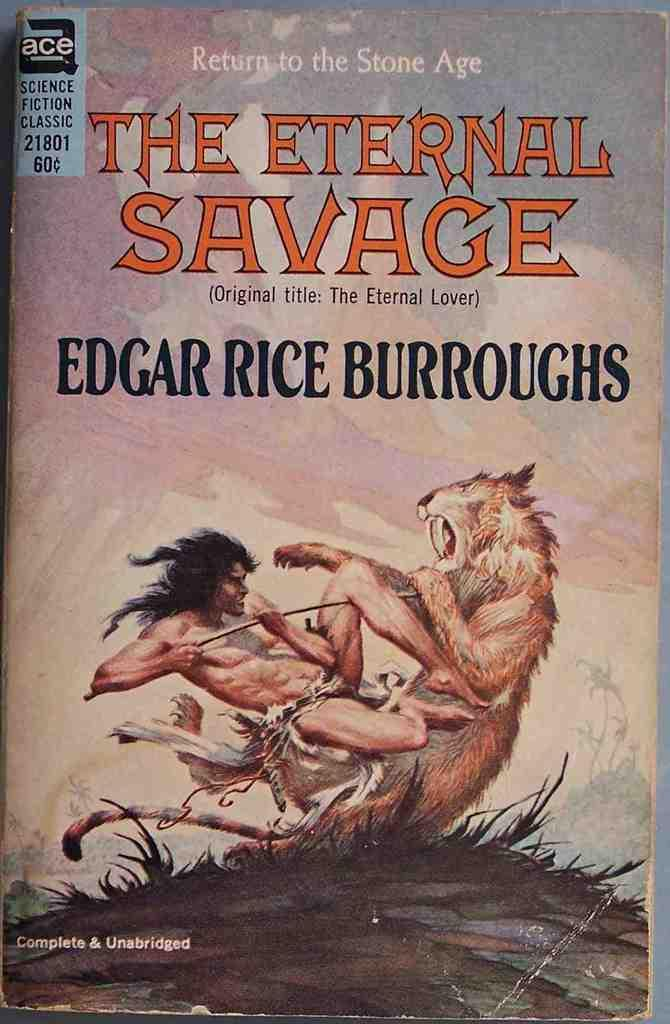<image>
Offer a succinct explanation of the picture presented. Return to the Stone Age The Eternal Savage Book that has the author Edgar Rice Burroughs. 